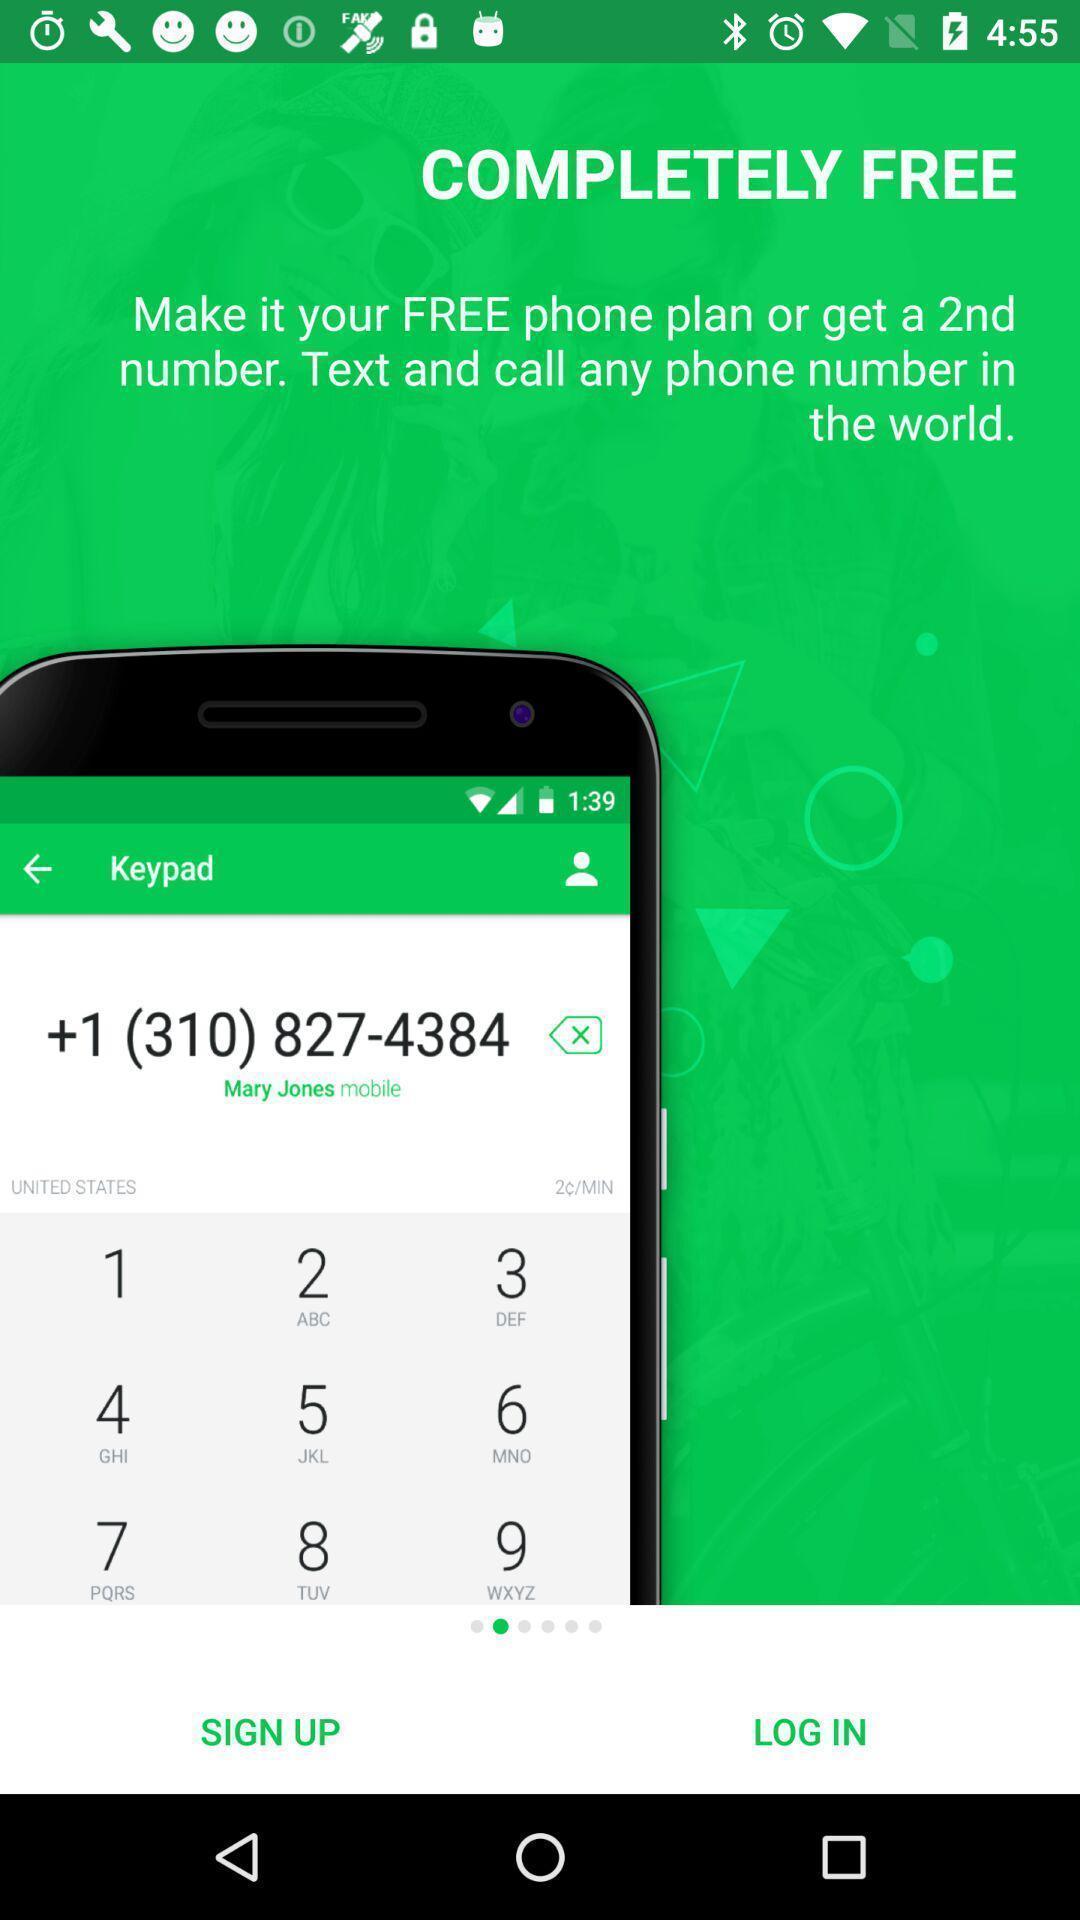Tell me about the visual elements in this screen capture. Sign in page displayed of communications app. 